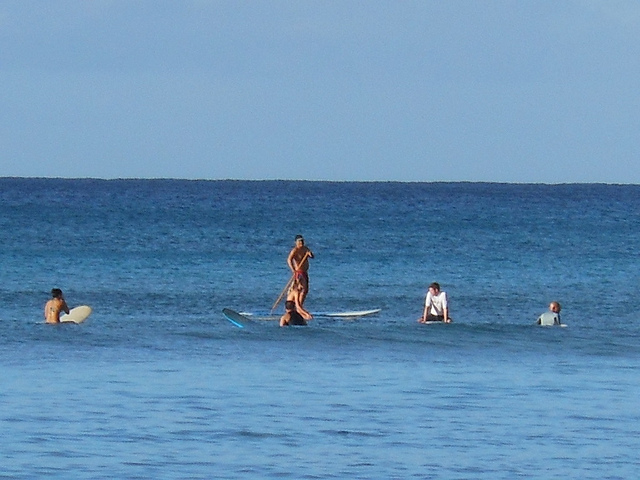What might be some of the benefits of engaging in the activities shown in the image? Participating in water activities such as stand-up paddleboarding and surfing offers numerous benefits. It's not only an excellent form of physical exercise, improving cardiovascular health, balance, and strength, but also has a positive impact on mental well-being. Being in the water and engaging with nature can reduce stress and promote a sense of tranquility. Furthermore, these activities often foster social connections, as they can be enjoyed in groups and often involve a supportive community of fellow enthusiasts. 